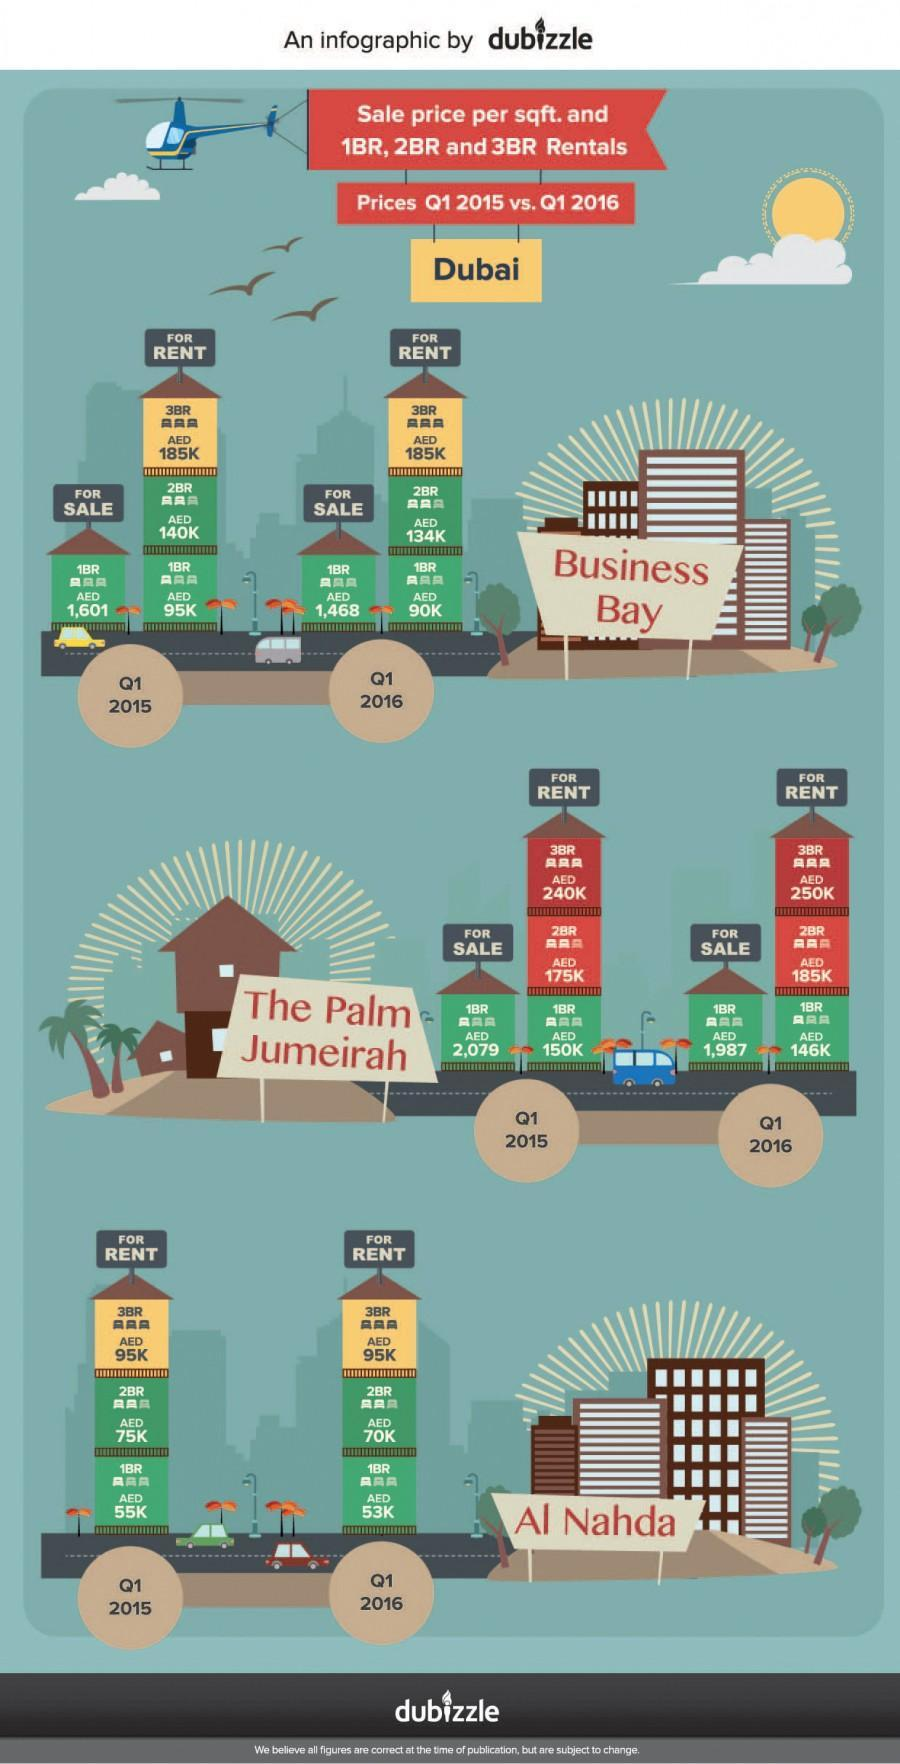What is the sales price per sqft. for a one-bedroom flat in the Palm Jumeirah, Dubai in Q1 2016?
Answer the question with a short phrase. AED 1,987 What is the sales price per sqft. for a one-bedroom flat in Business bay, Dubai in Q1 2016? AED 1,468 What is the rent price for a two-bedroom flat in the Palm Jumeirah, Dubai in Q1 2015? AED 175K What is the rent price for a three-bedroom flat in Al Nahda, Dubai in Q1 2015? AED 95K 